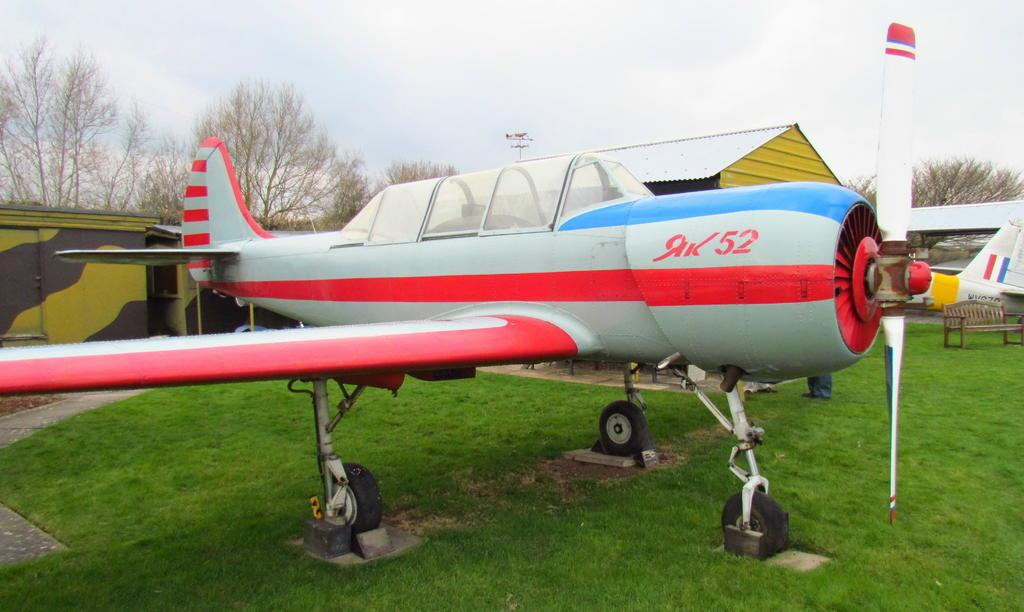<image>
Write a terse but informative summary of the picture. A striped red, white and blue small airplane sets on a grassy field, the label AK52 is on the side next to the propeller. 